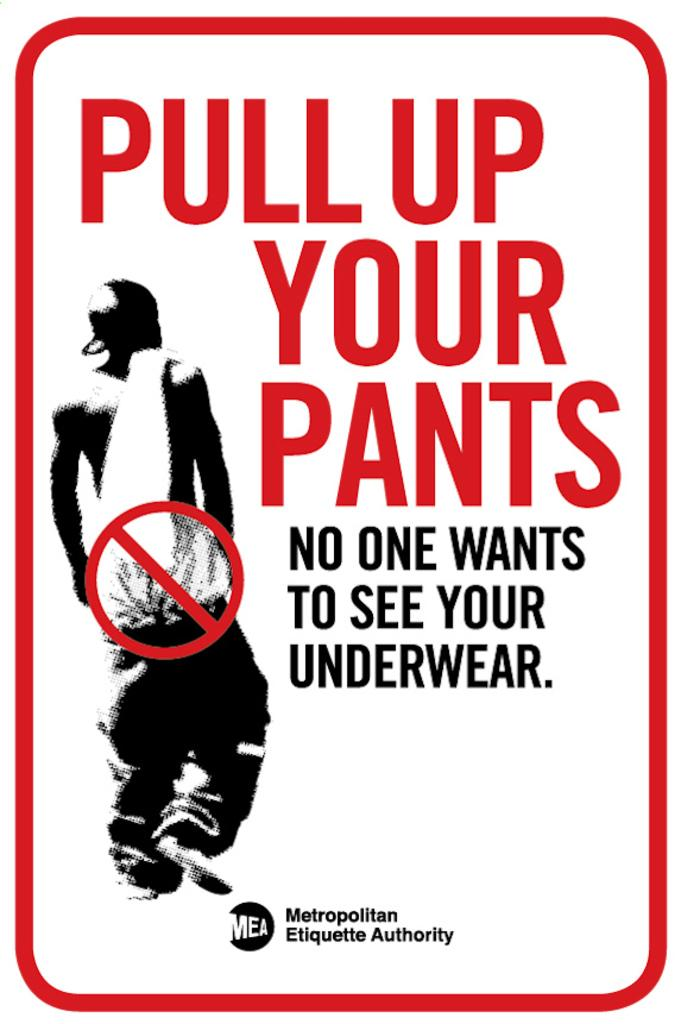<image>
Provide a brief description of the given image. a social message saying to pull up your pants 